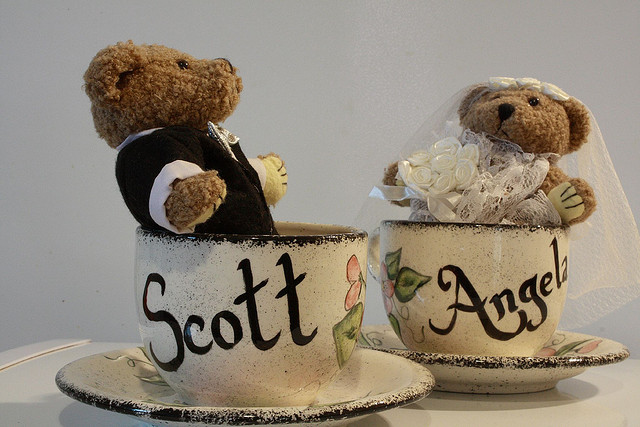Read and extract the text from this image. Scott Angela 